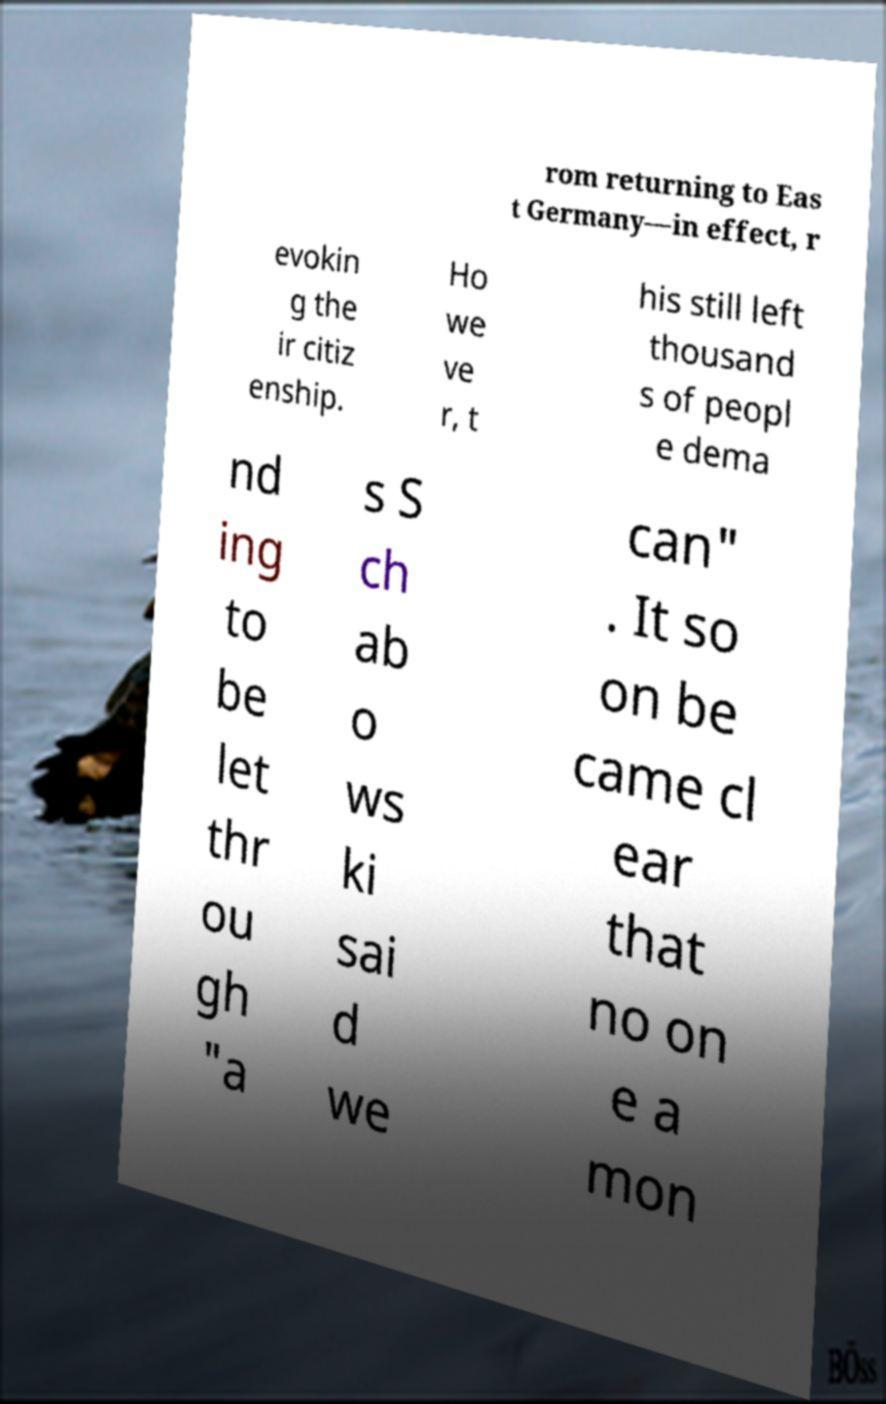Please identify and transcribe the text found in this image. rom returning to Eas t Germany—in effect, r evokin g the ir citiz enship. Ho we ve r, t his still left thousand s of peopl e dema nd ing to be let thr ou gh "a s S ch ab o ws ki sai d we can" . It so on be came cl ear that no on e a mon 